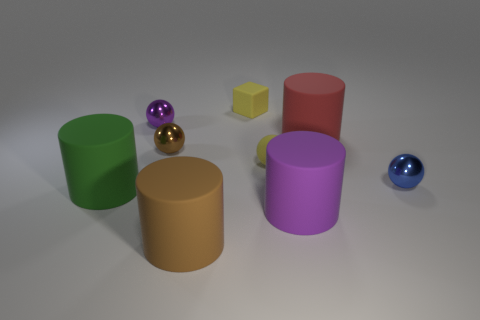What is the size of the matte sphere?
Make the answer very short. Small. There is a tiny metallic object that is both to the left of the large red thing and to the right of the tiny purple sphere; what is its shape?
Offer a terse response. Sphere. How many yellow objects are rubber spheres or big matte cubes?
Offer a very short reply. 1. Does the purple thing that is behind the red matte cylinder have the same size as the purple object that is in front of the green matte thing?
Provide a short and direct response. No. What number of things are blue things or brown metal things?
Offer a terse response. 2. Is there a brown object of the same shape as the tiny blue object?
Offer a terse response. Yes. Are there fewer red shiny cubes than yellow rubber things?
Provide a short and direct response. Yes. Does the blue object have the same shape as the brown shiny thing?
Ensure brevity in your answer.  Yes. What number of objects are red matte balls or big rubber cylinders in front of the large red cylinder?
Give a very brief answer. 3. What number of large brown things are there?
Ensure brevity in your answer.  1. 